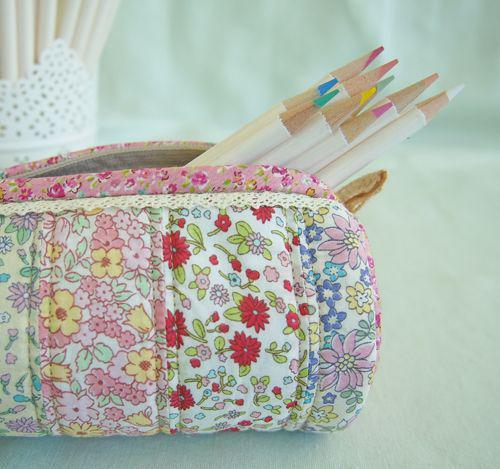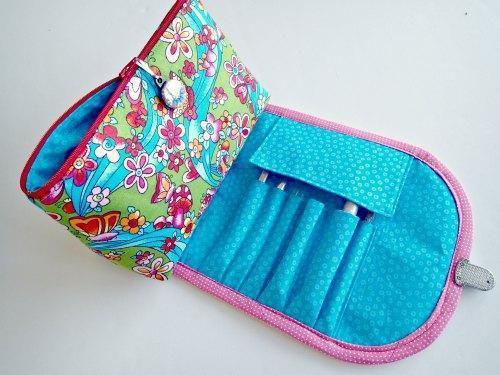The first image is the image on the left, the second image is the image on the right. For the images shown, is this caption "An image shows a set of colored pencils sticking out of a soft pencil case." true? Answer yes or no. Yes. The first image is the image on the left, the second image is the image on the right. For the images shown, is this caption "Color pencils are poking out of a pencil case in the image on the left." true? Answer yes or no. Yes. 